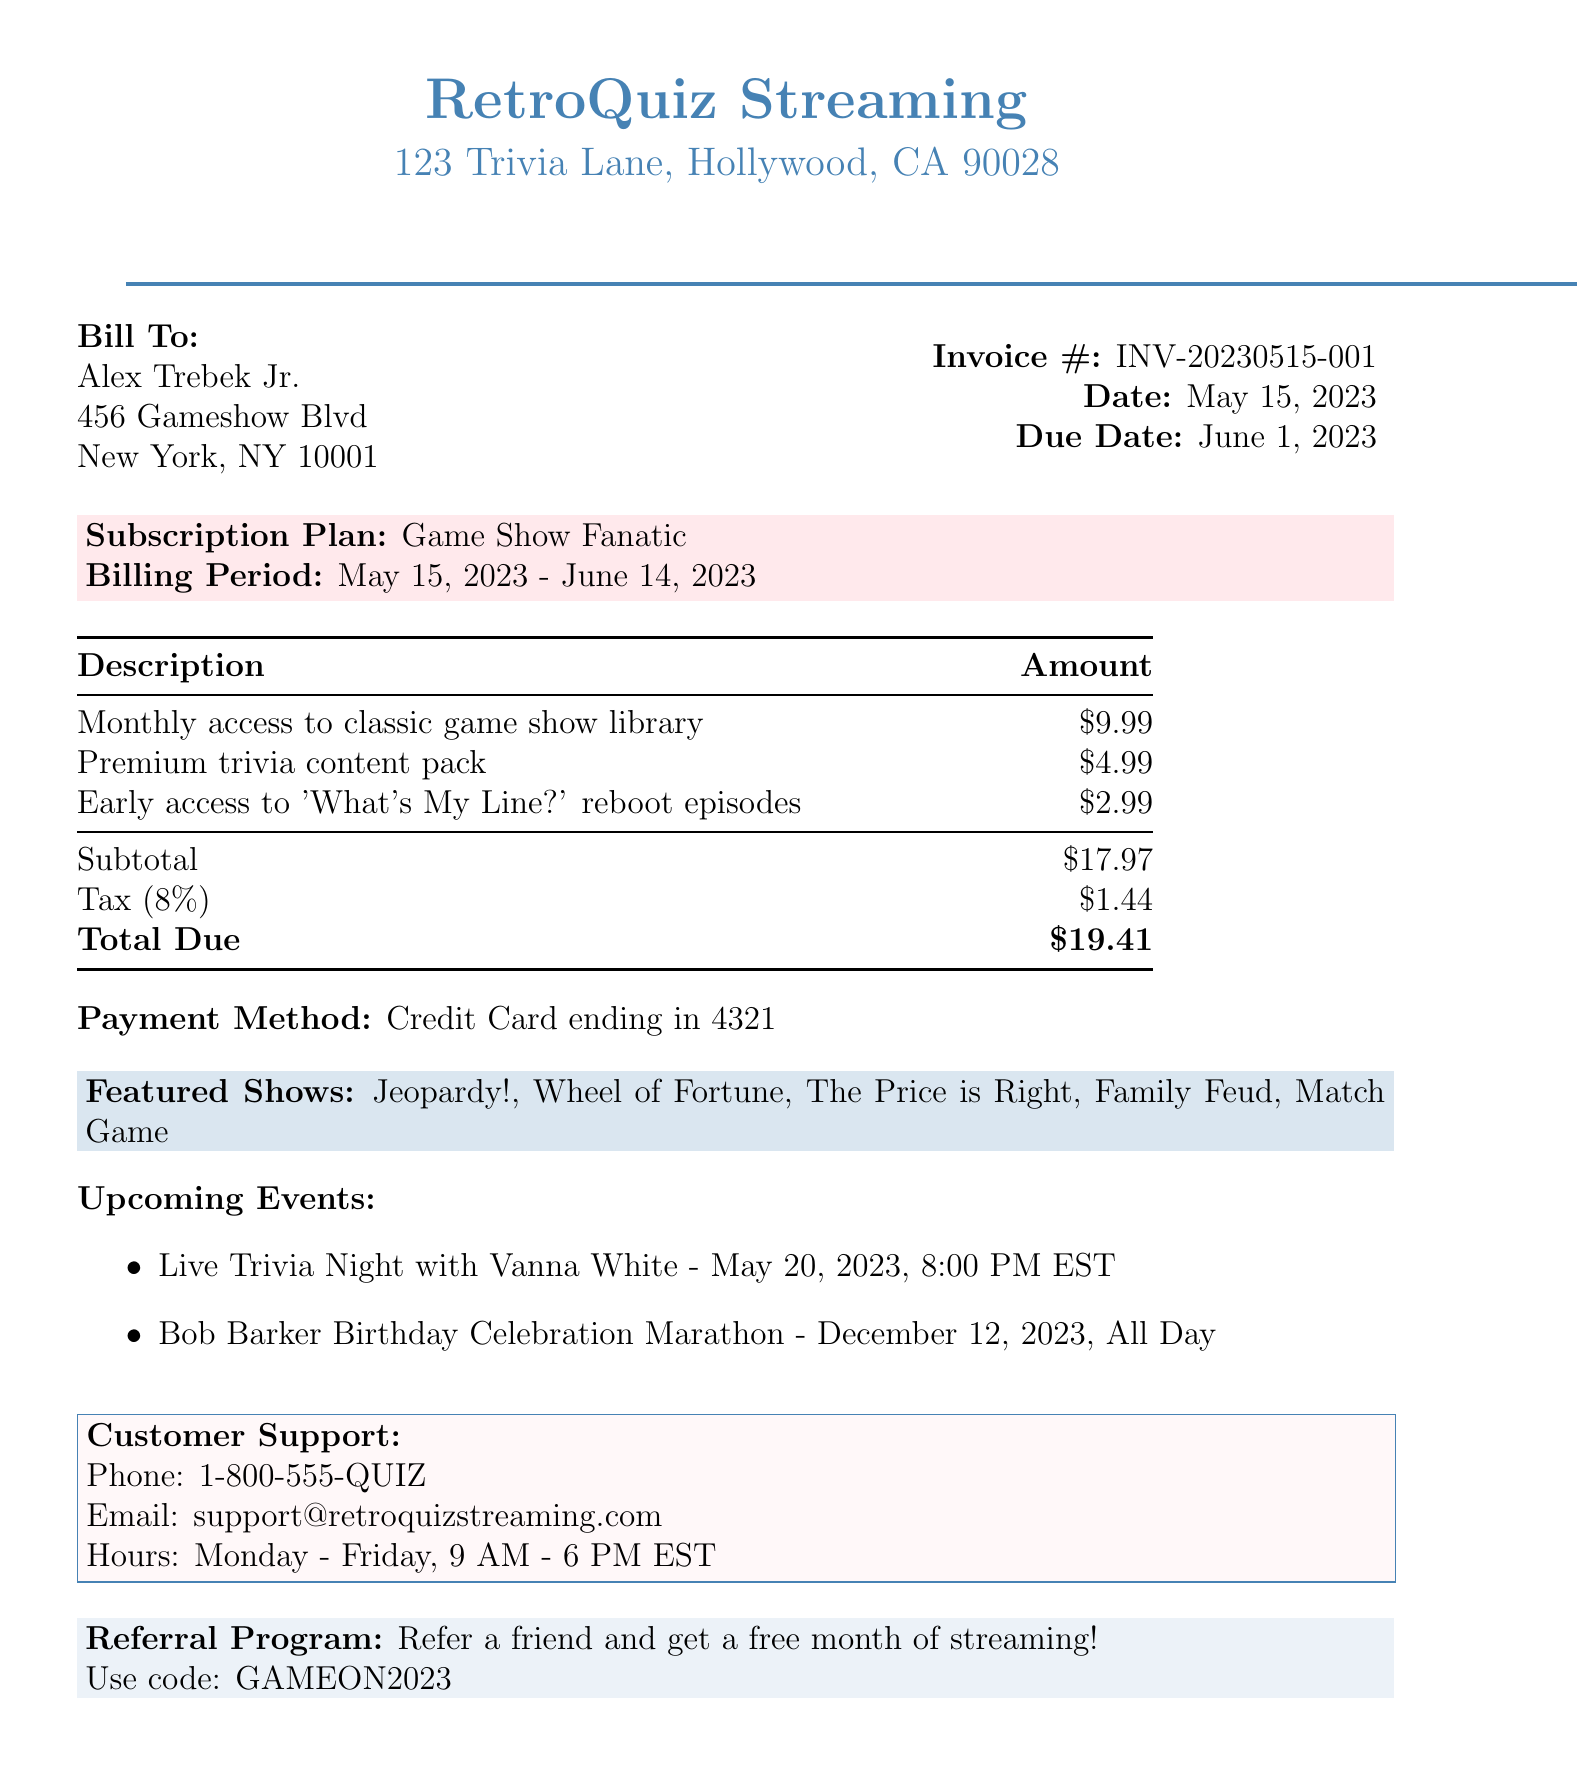What is the invoice number? The invoice number is specifically mentioned in the document as a unique identifier for this invoice.
Answer: INV-20230515-001 Who is the customer? The document clearly states the name of the individual who received the invoice.
Answer: Alex Trebek Jr What is the total due amount? The total due amount is calculated based on the subtotal and tax amount specified in the invoice.
Answer: $19.41 What is the billing period? The billing period indicates the duration for which the subscription service is provided, as stated in the document.
Answer: May 15, 2023 - June 14, 2023 How much is the tax amount? The tax amount is a specific calculation included in the invoice and is important for total due calculation.
Answer: $1.44 What subscription plan is mentioned? The subscription plan is explicitly listed to describe the service being subscribed to.
Answer: Game Show Fanatic What is the contact phone number for customer support? The document provides a specific phone number for customer support inquiries.
Answer: 1-800-555-QUIZ When is the Live Trivia Night event? The date and time for the upcoming event are clearly stated in the document, providing essential information for attendance.
Answer: May 20, 2023, 8:00 PM EST What is the referral program code? The code mentioned in the referral program is a specific detail for promotional purposes.
Answer: GAMEON2023 